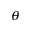Convert formula to latex. <formula><loc_0><loc_0><loc_500><loc_500>_ { \theta }</formula> 